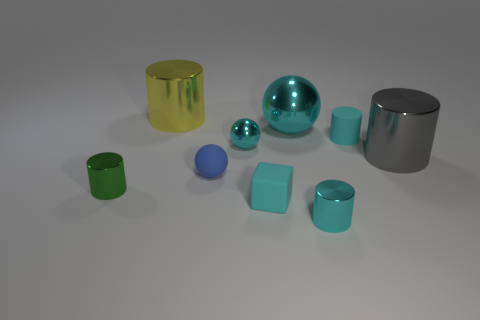Subtract all green cylinders. How many cylinders are left? 4 Subtract all yellow cylinders. How many cylinders are left? 4 Subtract all brown cylinders. Subtract all green cubes. How many cylinders are left? 5 Subtract all spheres. How many objects are left? 6 Add 3 metallic things. How many metallic things are left? 9 Add 1 tiny cylinders. How many tiny cylinders exist? 4 Subtract 0 blue blocks. How many objects are left? 9 Subtract all cyan shiny spheres. Subtract all cyan things. How many objects are left? 2 